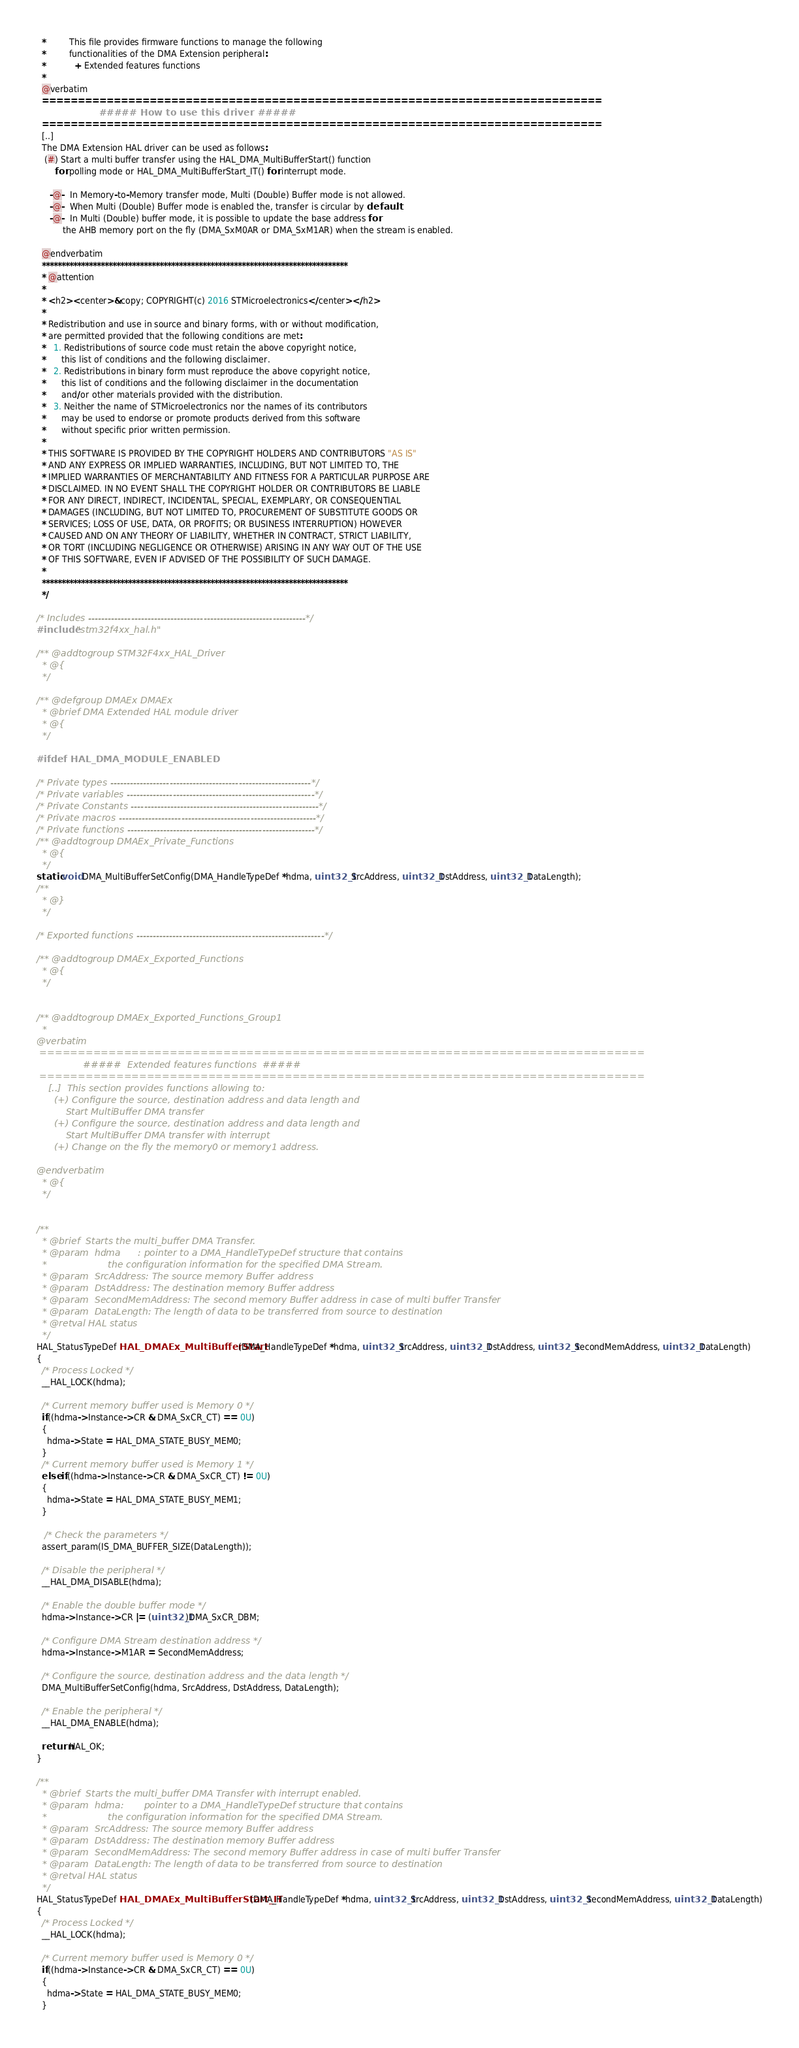<code> <loc_0><loc_0><loc_500><loc_500><_C_>  *         This file provides firmware functions to manage the following 
  *         functionalities of the DMA Extension peripheral:
  *           + Extended features functions
  *
  @verbatim
  ==============================================================================
                        ##### How to use this driver #####
  ==============================================================================
  [..]
  The DMA Extension HAL driver can be used as follows:
   (#) Start a multi buffer transfer using the HAL_DMA_MultiBufferStart() function
       for polling mode or HAL_DMA_MultiBufferStart_IT() for interrupt mode.
                   
     -@-  In Memory-to-Memory transfer mode, Multi (Double) Buffer mode is not allowed.
     -@-  When Multi (Double) Buffer mode is enabled the, transfer is circular by default.
     -@-  In Multi (Double) buffer mode, it is possible to update the base address for 
          the AHB memory port on the fly (DMA_SxM0AR or DMA_SxM1AR) when the stream is enabled. 
  
  @endverbatim
  ******************************************************************************
  * @attention
  *
  * <h2><center>&copy; COPYRIGHT(c) 2016 STMicroelectronics</center></h2>
  *
  * Redistribution and use in source and binary forms, with or without modification,
  * are permitted provided that the following conditions are met:
  *   1. Redistributions of source code must retain the above copyright notice,
  *      this list of conditions and the following disclaimer.
  *   2. Redistributions in binary form must reproduce the above copyright notice,
  *      this list of conditions and the following disclaimer in the documentation
  *      and/or other materials provided with the distribution.
  *   3. Neither the name of STMicroelectronics nor the names of its contributors
  *      may be used to endorse or promote products derived from this software
  *      without specific prior written permission.
  *
  * THIS SOFTWARE IS PROVIDED BY THE COPYRIGHT HOLDERS AND CONTRIBUTORS "AS IS"
  * AND ANY EXPRESS OR IMPLIED WARRANTIES, INCLUDING, BUT NOT LIMITED TO, THE
  * IMPLIED WARRANTIES OF MERCHANTABILITY AND FITNESS FOR A PARTICULAR PURPOSE ARE
  * DISCLAIMED. IN NO EVENT SHALL THE COPYRIGHT HOLDER OR CONTRIBUTORS BE LIABLE
  * FOR ANY DIRECT, INDIRECT, INCIDENTAL, SPECIAL, EXEMPLARY, OR CONSEQUENTIAL
  * DAMAGES (INCLUDING, BUT NOT LIMITED TO, PROCUREMENT OF SUBSTITUTE GOODS OR
  * SERVICES; LOSS OF USE, DATA, OR PROFITS; OR BUSINESS INTERRUPTION) HOWEVER
  * CAUSED AND ON ANY THEORY OF LIABILITY, WHETHER IN CONTRACT, STRICT LIABILITY,
  * OR TORT (INCLUDING NEGLIGENCE OR OTHERWISE) ARISING IN ANY WAY OUT OF THE USE
  * OF THIS SOFTWARE, EVEN IF ADVISED OF THE POSSIBILITY OF SUCH DAMAGE.
  *
  ******************************************************************************
  */

/* Includes ------------------------------------------------------------------*/
#include "stm32f4xx_hal.h"

/** @addtogroup STM32F4xx_HAL_Driver
  * @{
  */

/** @defgroup DMAEx DMAEx
  * @brief DMA Extended HAL module driver
  * @{
  */

#ifdef HAL_DMA_MODULE_ENABLED

/* Private types -------------------------------------------------------------*/
/* Private variables ---------------------------------------------------------*/
/* Private Constants ---------------------------------------------------------*/
/* Private macros ------------------------------------------------------------*/
/* Private functions ---------------------------------------------------------*/
/** @addtogroup DMAEx_Private_Functions
  * @{
  */
static void DMA_MultiBufferSetConfig(DMA_HandleTypeDef *hdma, uint32_t SrcAddress, uint32_t DstAddress, uint32_t DataLength);
/**
  * @}
  */

/* Exported functions ---------------------------------------------------------*/

/** @addtogroup DMAEx_Exported_Functions
  * @{
  */


/** @addtogroup DMAEx_Exported_Functions_Group1
  *
@verbatim   
 ===============================================================================
                #####  Extended features functions  #####
 ===============================================================================  
    [..]  This section provides functions allowing to:
      (+) Configure the source, destination address and data length and 
          Start MultiBuffer DMA transfer
      (+) Configure the source, destination address and data length and 
          Start MultiBuffer DMA transfer with interrupt
      (+) Change on the fly the memory0 or memory1 address.
      
@endverbatim
  * @{
  */


/**
  * @brief  Starts the multi_buffer DMA Transfer.
  * @param  hdma      : pointer to a DMA_HandleTypeDef structure that contains
  *                     the configuration information for the specified DMA Stream.  
  * @param  SrcAddress: The source memory Buffer address
  * @param  DstAddress: The destination memory Buffer address
  * @param  SecondMemAddress: The second memory Buffer address in case of multi buffer Transfer  
  * @param  DataLength: The length of data to be transferred from source to destination
  * @retval HAL status
  */
HAL_StatusTypeDef HAL_DMAEx_MultiBufferStart(DMA_HandleTypeDef *hdma, uint32_t SrcAddress, uint32_t DstAddress, uint32_t SecondMemAddress, uint32_t DataLength)
{
  /* Process Locked */
  __HAL_LOCK(hdma);

  /* Current memory buffer used is Memory 0 */
  if((hdma->Instance->CR & DMA_SxCR_CT) == 0U)
  {
    hdma->State = HAL_DMA_STATE_BUSY_MEM0;
  }
  /* Current memory buffer used is Memory 1 */
  else if((hdma->Instance->CR & DMA_SxCR_CT) != 0U)
  {
    hdma->State = HAL_DMA_STATE_BUSY_MEM1;
  }

   /* Check the parameters */
  assert_param(IS_DMA_BUFFER_SIZE(DataLength));

  /* Disable the peripheral */
  __HAL_DMA_DISABLE(hdma);  

  /* Enable the double buffer mode */
  hdma->Instance->CR |= (uint32_t)DMA_SxCR_DBM;

  /* Configure DMA Stream destination address */
  hdma->Instance->M1AR = SecondMemAddress;

  /* Configure the source, destination address and the data length */
  DMA_MultiBufferSetConfig(hdma, SrcAddress, DstAddress, DataLength);

  /* Enable the peripheral */
  __HAL_DMA_ENABLE(hdma);

  return HAL_OK;
}

/**
  * @brief  Starts the multi_buffer DMA Transfer with interrupt enabled.
  * @param  hdma:       pointer to a DMA_HandleTypeDef structure that contains
  *                     the configuration information for the specified DMA Stream.  
  * @param  SrcAddress: The source memory Buffer address
  * @param  DstAddress: The destination memory Buffer address
  * @param  SecondMemAddress: The second memory Buffer address in case of multi buffer Transfer  
  * @param  DataLength: The length of data to be transferred from source to destination
  * @retval HAL status
  */
HAL_StatusTypeDef HAL_DMAEx_MultiBufferStart_IT(DMA_HandleTypeDef *hdma, uint32_t SrcAddress, uint32_t DstAddress, uint32_t SecondMemAddress, uint32_t DataLength)
{
  /* Process Locked */
  __HAL_LOCK(hdma);

  /* Current memory buffer used is Memory 0 */
  if((hdma->Instance->CR & DMA_SxCR_CT) == 0U)
  {
    hdma->State = HAL_DMA_STATE_BUSY_MEM0;
  }</code> 